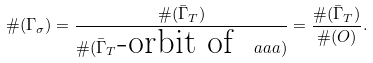<formula> <loc_0><loc_0><loc_500><loc_500>\# ( \Gamma _ { \sigma } ) = \frac { \# ( \bar { \Gamma } _ { T } ) } { \# ( \bar { \Gamma } _ { T } \text {-orbit of } \ a a a ) } = \frac { \# ( \bar { \Gamma } _ { T } ) } { \# ( O ) } .</formula> 